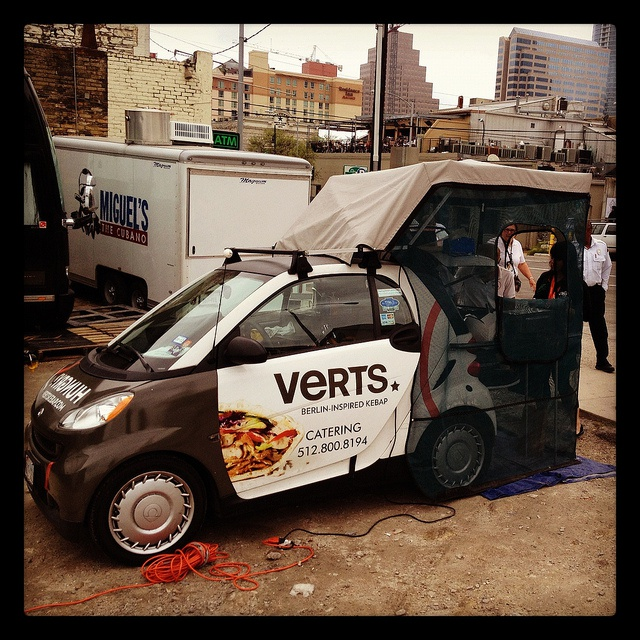Describe the objects in this image and their specific colors. I can see car in black, lightgray, gray, and maroon tones, truck in black, lightgray, darkgray, and gray tones, people in black, darkgray, lightgray, and gray tones, people in black, gray, and maroon tones, and people in black, maroon, gray, and brown tones in this image. 